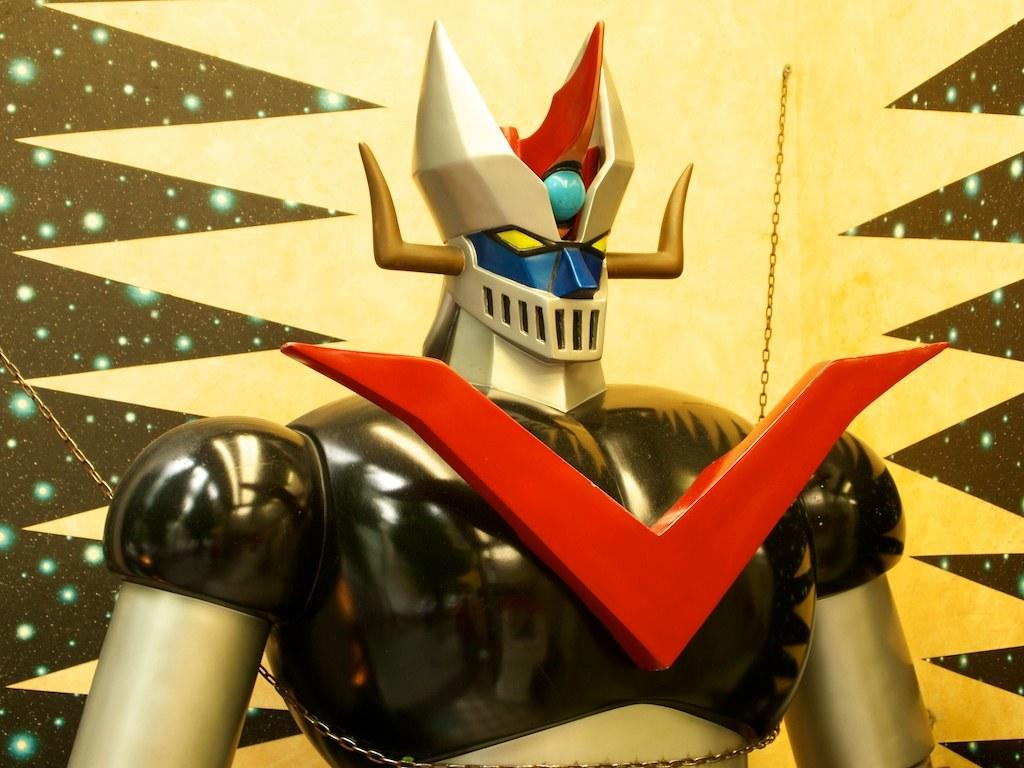What object can be seen in the image? There is a toy in the image. What feature is attached to the toy? The toy has a chain around it. What can be seen behind the toy? There is a wall visible behind the toy. What type of crown is being worn by the toy in the image? There is no crown present in the image; the toy has a chain around it. 